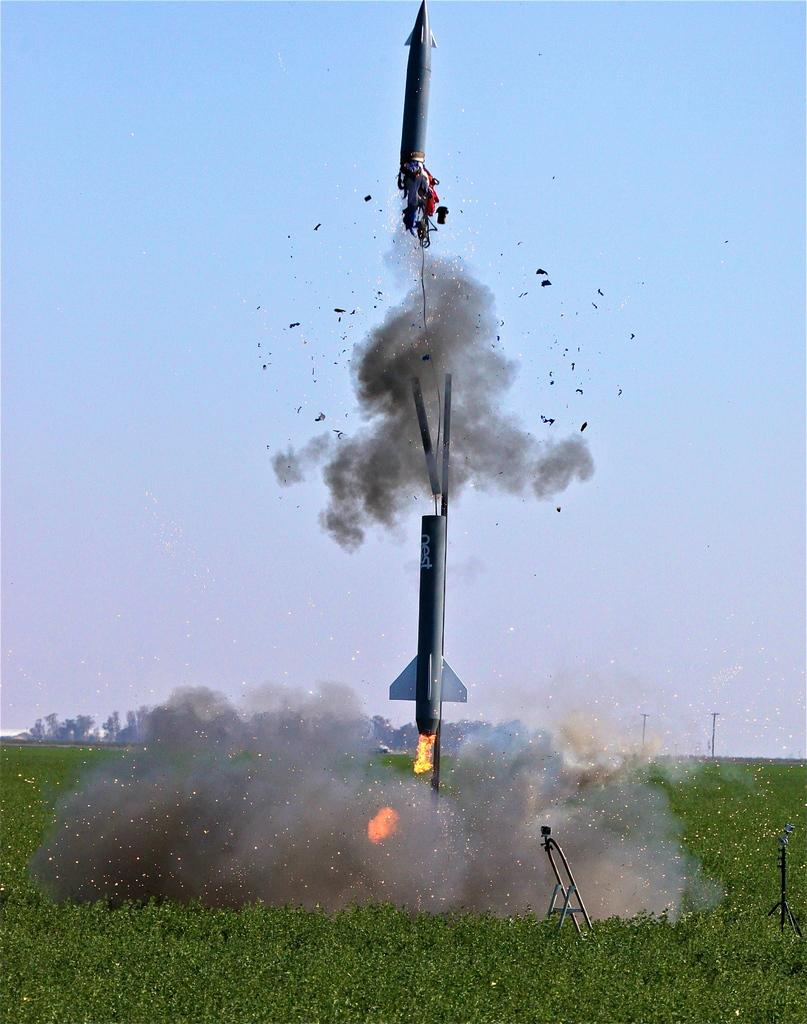What is the main subject of the image? The main subject of the image is a rocket flying. What other objects can be seen in the image? There is a ladder and grass visible in the image. What type of sweater is the giraffe wearing in the image? There is no giraffe or sweater present in the image. How is the coal being used in the image? There is no coal present in the image. 